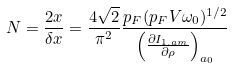Convert formula to latex. <formula><loc_0><loc_0><loc_500><loc_500>N = \frac { 2 x } { \delta x } = \frac { 4 \sqrt { 2 } } { \pi ^ { 2 } } \frac { p _ { F } ( p _ { F } V \omega _ { 0 } ) ^ { 1 / 2 } } { \left ( \frac { \partial I _ { 1 . a m } } { \partial \rho } \right ) _ { a _ { 0 } } }</formula> 